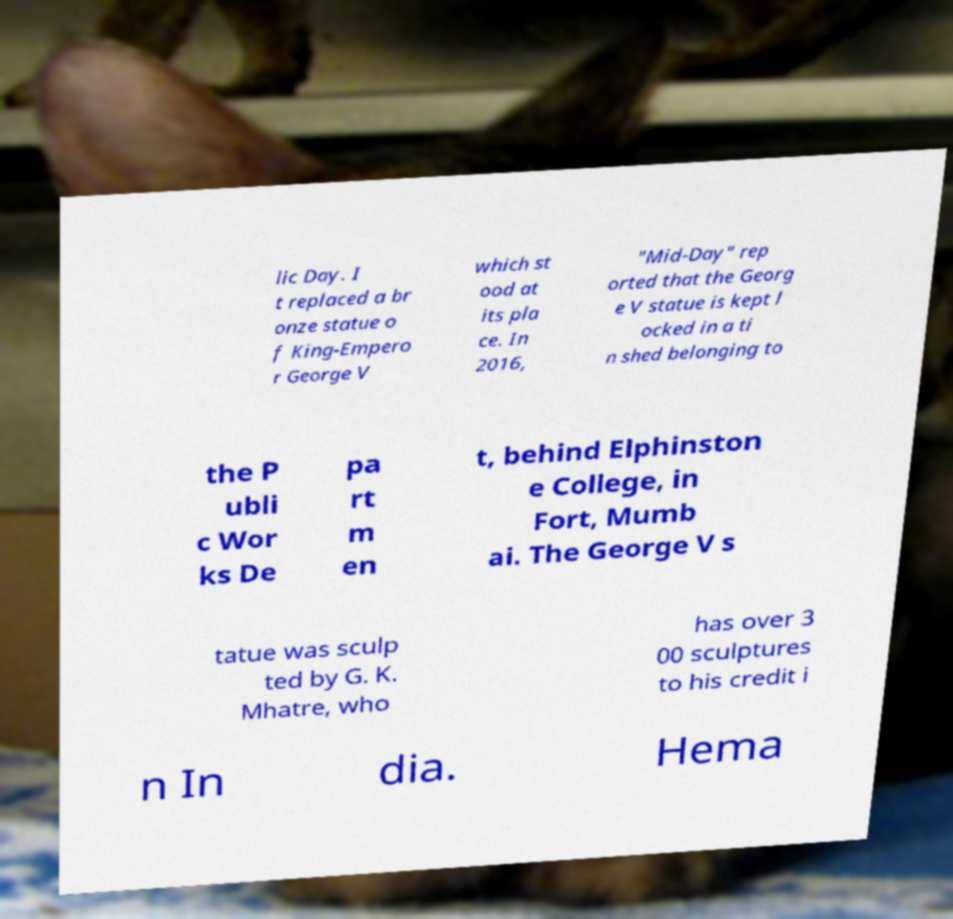Could you extract and type out the text from this image? lic Day. I t replaced a br onze statue o f King-Empero r George V which st ood at its pla ce. In 2016, "Mid-Day" rep orted that the Georg e V statue is kept l ocked in a ti n shed belonging to the P ubli c Wor ks De pa rt m en t, behind Elphinston e College, in Fort, Mumb ai. The George V s tatue was sculp ted by G. K. Mhatre, who has over 3 00 sculptures to his credit i n In dia. Hema 